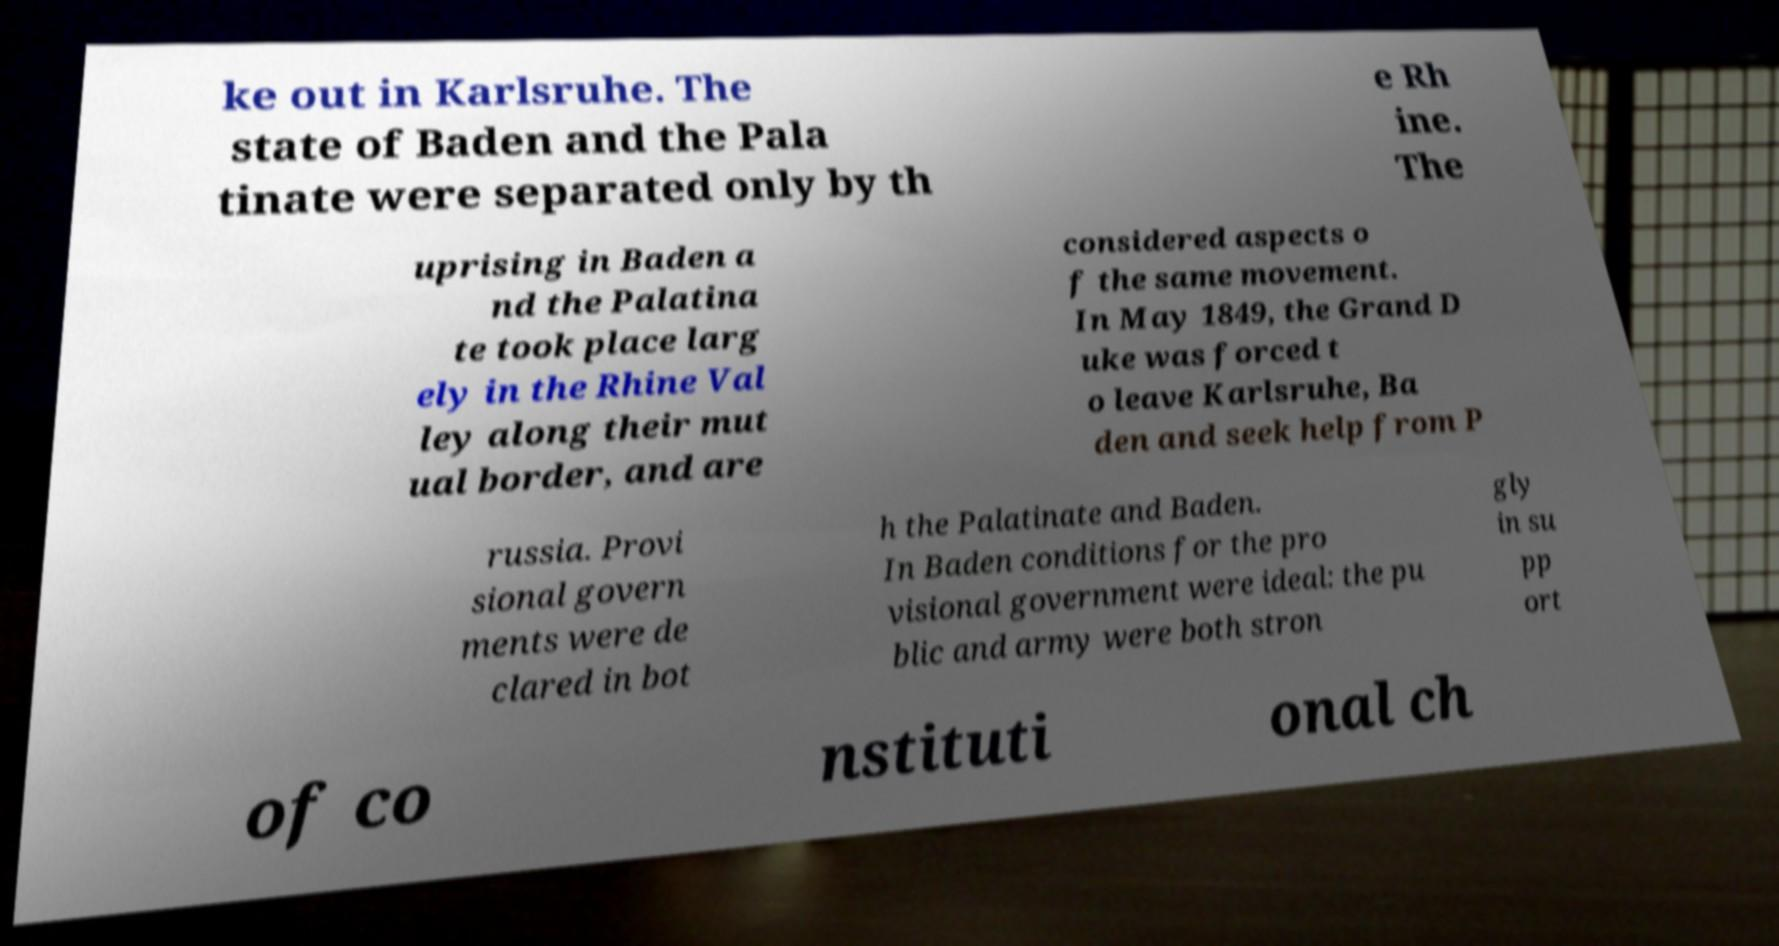For documentation purposes, I need the text within this image transcribed. Could you provide that? ke out in Karlsruhe. The state of Baden and the Pala tinate were separated only by th e Rh ine. The uprising in Baden a nd the Palatina te took place larg ely in the Rhine Val ley along their mut ual border, and are considered aspects o f the same movement. In May 1849, the Grand D uke was forced t o leave Karlsruhe, Ba den and seek help from P russia. Provi sional govern ments were de clared in bot h the Palatinate and Baden. In Baden conditions for the pro visional government were ideal: the pu blic and army were both stron gly in su pp ort of co nstituti onal ch 